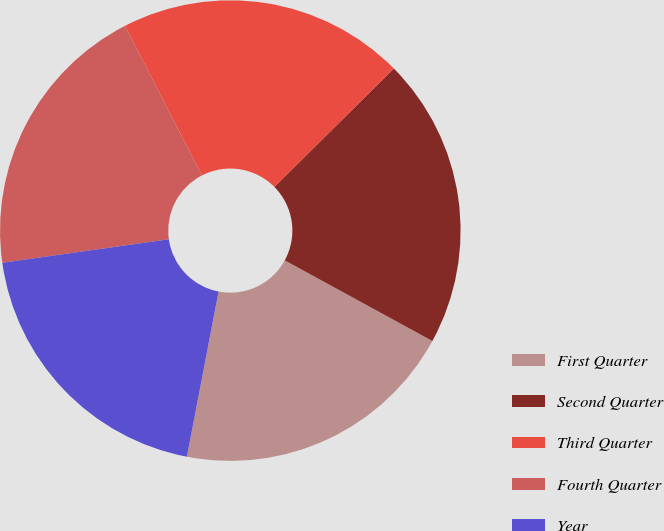Convert chart. <chart><loc_0><loc_0><loc_500><loc_500><pie_chart><fcel>First Quarter<fcel>Second Quarter<fcel>Third Quarter<fcel>Fourth Quarter<fcel>Year<nl><fcel>20.06%<fcel>20.39%<fcel>20.13%<fcel>19.67%<fcel>19.75%<nl></chart> 